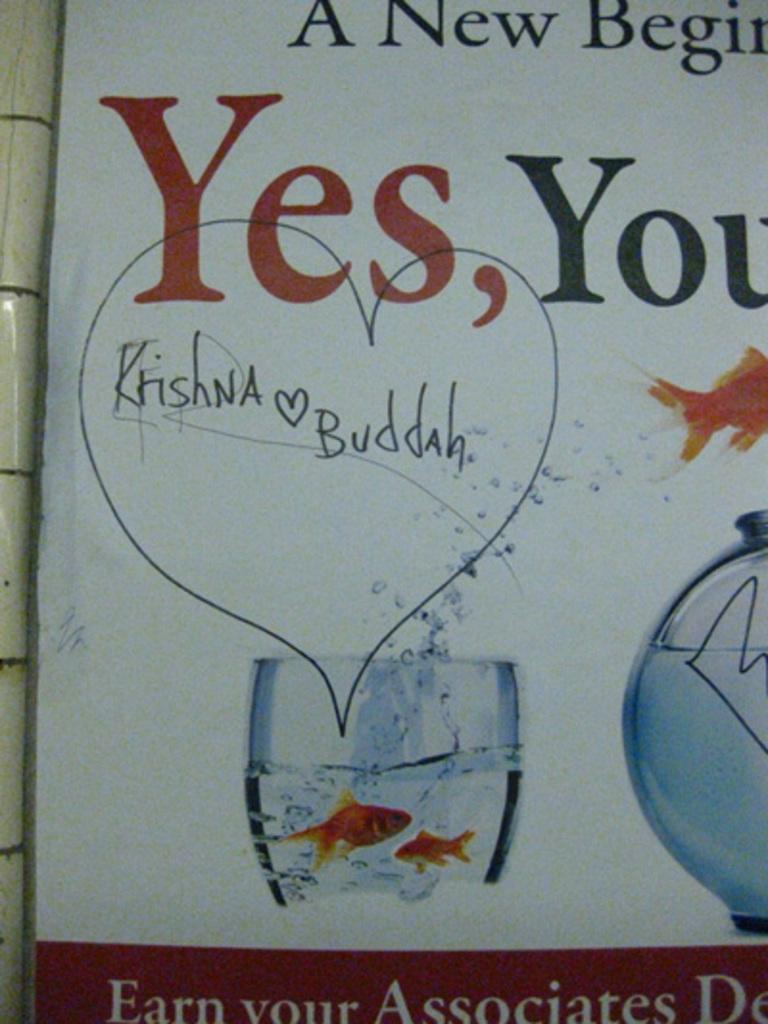What is the main object in the image? There is a board in the image. What is featured on the board? The board contains text and images of a glass bowl and a glass. What is inside the glass? There are two fishes in the water inside the glass. What type of rake is being used by the carpenter in the image? There is no carpenter or rake present in the image. What kind of sea creatures can be seen in the image? There are no sea creatures present in the image; it features two fishes in a glass of water. 